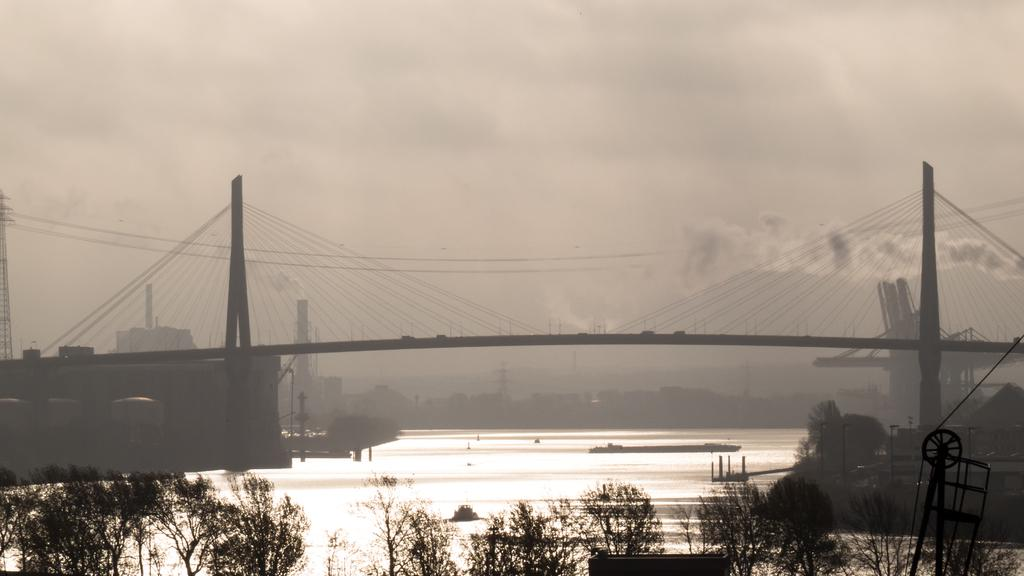What type of structure is present in the image? There is a roadway bridge in the image. What is located beneath the bridge? A river is flowing under the bridge. What can be seen in the background of the image? There are many trees in the image. How would you describe the sky in the image? The sky is slightly cloudy in the image. Can you tell me how many cows are grazing near the coast in the image? There are no cows or coast present in the image; it features a roadway bridge, a river, trees, and a slightly cloudy sky. 